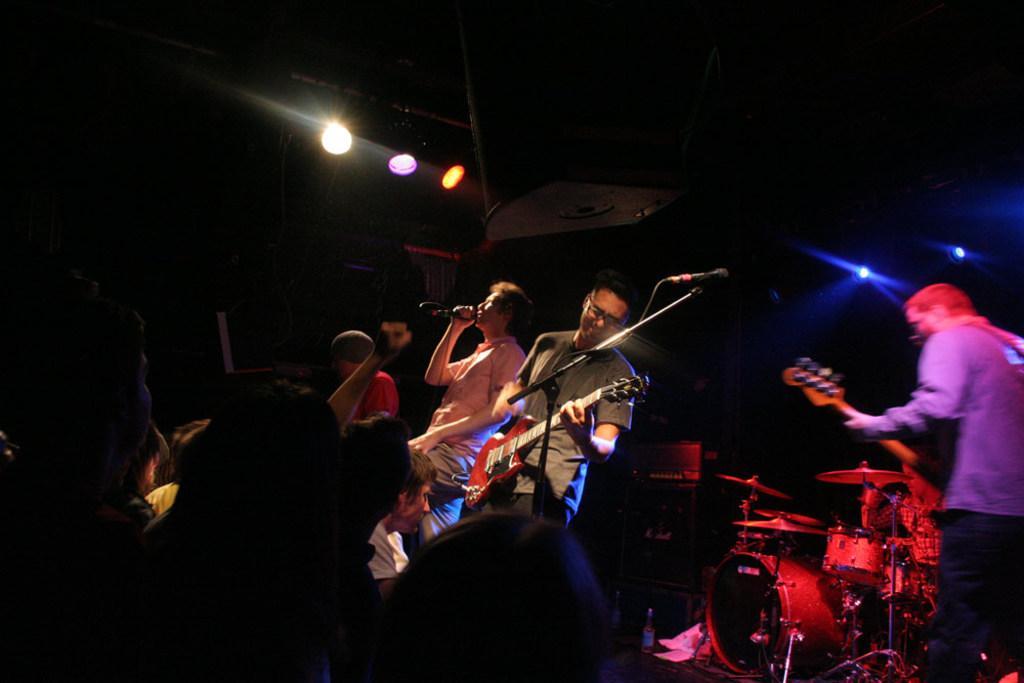Could you give a brief overview of what you see in this image? Here we can see a group of people are standing and playing guitar, and here is the microphone and stand, and at back here are the musical drums and here are the lights. 